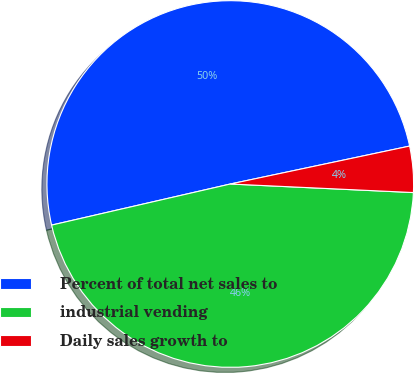<chart> <loc_0><loc_0><loc_500><loc_500><pie_chart><fcel>Percent of total net sales to<fcel>industrial vending<fcel>Daily sales growth to<nl><fcel>50.28%<fcel>45.66%<fcel>4.06%<nl></chart> 